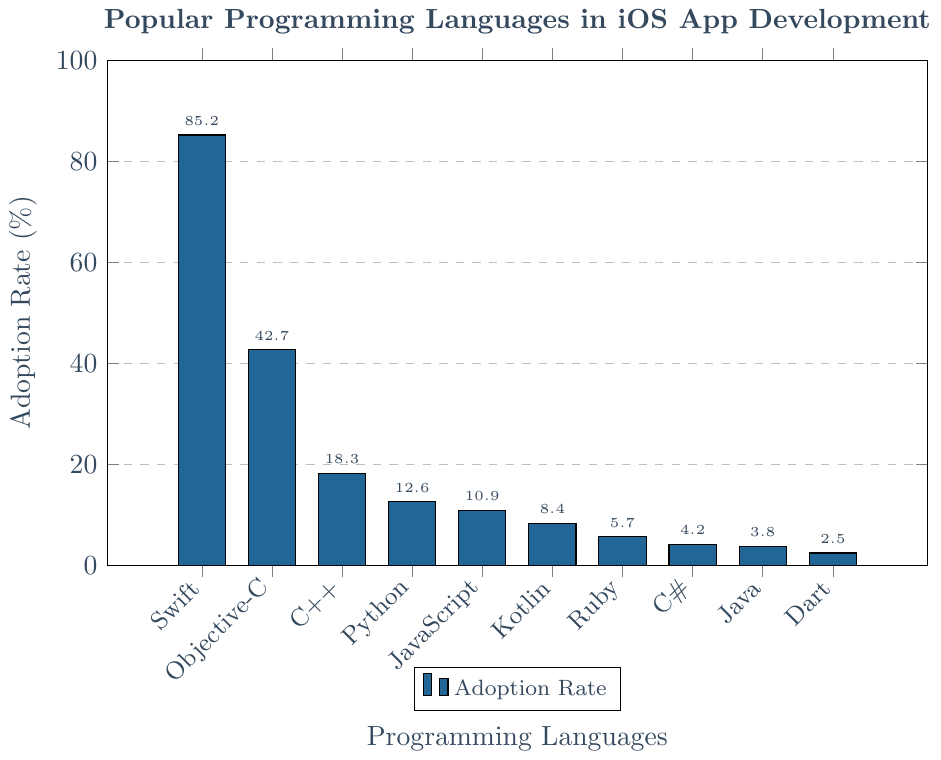What is the adoption rate of Swift compared to Objective-C? To find this, look at the y-values of the bars for Swift and Objective-C. Swift has an adoption rate of 85.2%, while Objective-C has 42.7%. The comparison shows Swift is more widely used.
Answer: Swift: 85.2%, Objective-C: 42.7% Which programming language has the lowest adoption rate? Look at the heights of the bars to identify the shortest one. The shortest bar corresponds to Dart, with an adoption rate of 2.5%.
Answer: Dart How many languages have an adoption rate higher than 10%? Count the number of bars with a y-value greater than 10%. Swift, Objective-C, C++, and Python all have adoption rates above 10%.
Answer: 4 What is the difference between the highest and the lowest adoption rates? Identify the highest and lowest y-values. The highest is Swift at 85.2%, and the lowest is Dart at 2.5%. Subtract the lowest from the highest: 85.2% - 2.5% = 82.7%.
Answer: 82.7% What is the sum of the adoption rates for Kotlin, Ruby, and C#? Add the adoption rates for these languages: Kotlin (8.4%) + Ruby (5.7%) + C# (4.2%). The calculation is 8.4 + 5.7 + 4.2 = 18.3.
Answer: 18.3% Which language has an adoption rate closest to 20%? Compare the adoption rates with 20% and look for the closest one. C++ has an adoption rate of 18.3%, which is the closest to 20%.
Answer: C++ How much higher is Swift's adoption rate compared to Python’s? Subtract Python’s adoption rate from Swift’s: 85.2% - 12.6% = 72.6%.
Answer: 72.6% Arrange the languages in descending order based on their adoption rates. Sort the languages by the height of their bars from tallest to shortest: Swift, Objective-C, C++, Python, JavaScript, Kotlin, Ruby, C#, Java, Dart.
Answer: Swift, Objective-C, C++, Python, JavaScript, Kotlin, Ruby, C#, Java, Dart Which language has closest adoption rates, JavaScript or Kotlin? Compare the adoption rates: JavaScript (10.9%) and Kotlin (8.4%). The difference is 10.9% - 8.4% = 2.5%.
Answer: JavaScript and Kotlin What is the average adoption rate of the top three languages? The top three languages by adoption rate are Swift (85.2%), Objective-C (42.7%), and C++ (18.3%). Calculate the average: (85.2% + 42.7% + 18.3%) / 3 = 146.2 / 3 = 48.73%.
Answer: 48.73% 